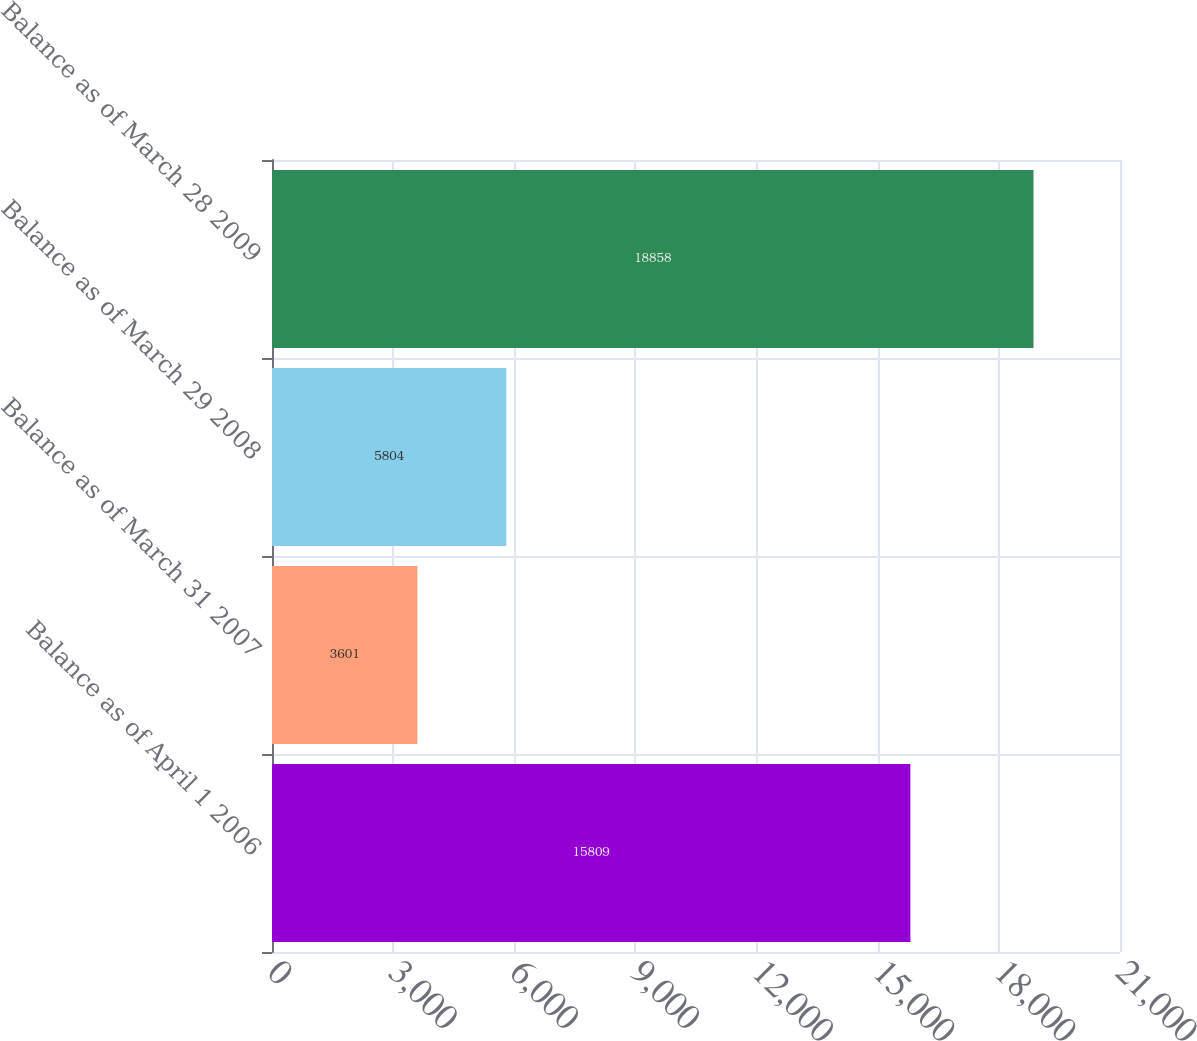<chart> <loc_0><loc_0><loc_500><loc_500><bar_chart><fcel>Balance as of April 1 2006<fcel>Balance as of March 31 2007<fcel>Balance as of March 29 2008<fcel>Balance as of March 28 2009<nl><fcel>15809<fcel>3601<fcel>5804<fcel>18858<nl></chart> 